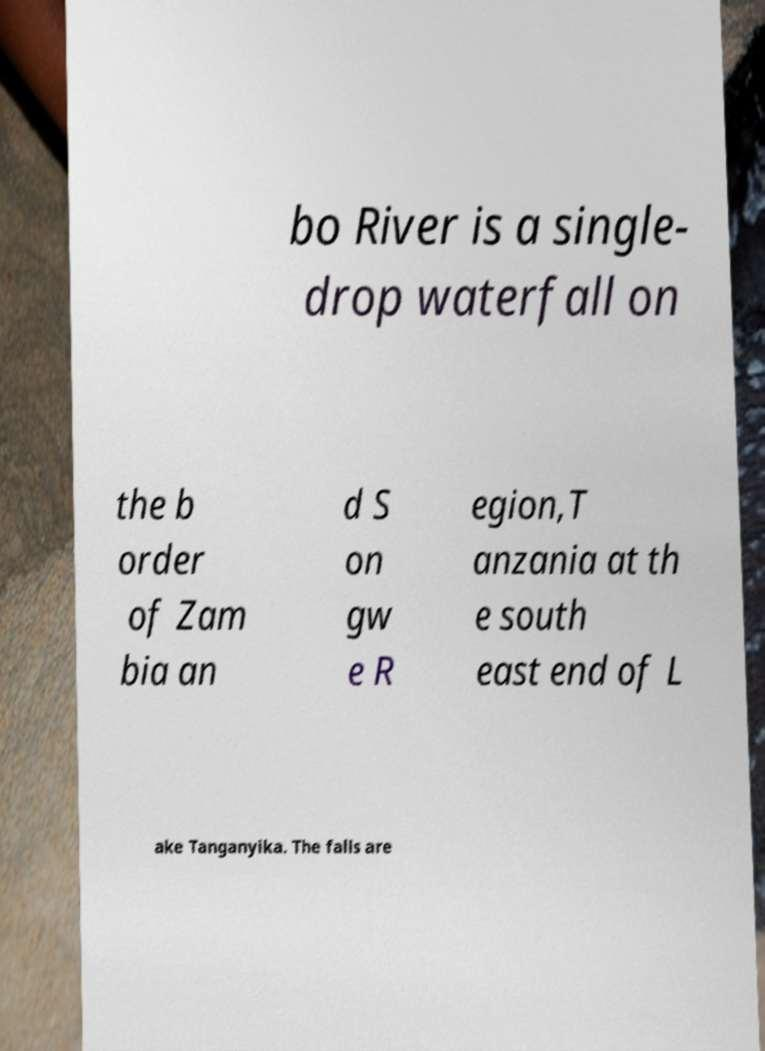What messages or text are displayed in this image? I need them in a readable, typed format. bo River is a single- drop waterfall on the b order of Zam bia an d S on gw e R egion,T anzania at th e south east end of L ake Tanganyika. The falls are 